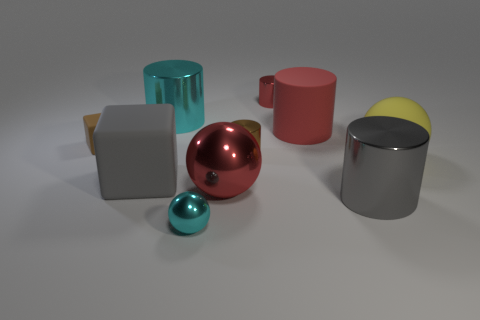What size is the metallic sphere in front of the big red thing that is in front of the small brown cylinder?
Give a very brief answer. Small. Is there a rubber ball?
Offer a terse response. Yes. There is a small rubber thing that is in front of the big red rubber cylinder; what number of blocks are on the right side of it?
Offer a very short reply. 1. There is a big gray metal object that is in front of the brown cylinder; what is its shape?
Make the answer very short. Cylinder. There is a large thing left of the big metal cylinder that is behind the large gray object that is right of the small red metallic thing; what is its material?
Make the answer very short. Rubber. What number of other things are the same size as the red shiny sphere?
Your answer should be very brief. 5. There is a big cyan object that is the same shape as the small red shiny thing; what is it made of?
Provide a succinct answer. Metal. What is the color of the small matte cube?
Ensure brevity in your answer.  Brown. What color is the big matte object on the left side of the red object in front of the red matte object?
Ensure brevity in your answer.  Gray. There is a big matte cube; is its color the same as the metallic cylinder that is in front of the gray rubber cube?
Ensure brevity in your answer.  Yes. 